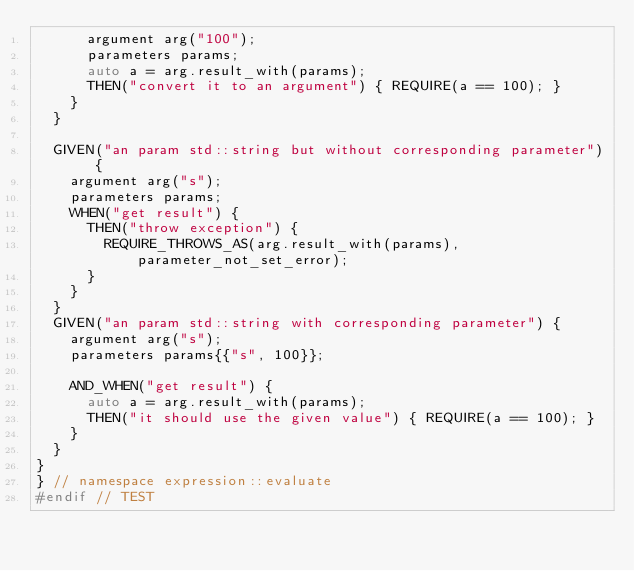Convert code to text. <code><loc_0><loc_0><loc_500><loc_500><_C++_>      argument arg("100");
      parameters params;
      auto a = arg.result_with(params);
      THEN("convert it to an argument") { REQUIRE(a == 100); }
    }
  }

  GIVEN("an param std::string but without corresponding parameter") {
    argument arg("s");
    parameters params;
    WHEN("get result") {
      THEN("throw exception") {
        REQUIRE_THROWS_AS(arg.result_with(params), parameter_not_set_error);
      }
    }
  }
  GIVEN("an param std::string with corresponding parameter") {
    argument arg("s");
    parameters params{{"s", 100}};

    AND_WHEN("get result") {
      auto a = arg.result_with(params);
      THEN("it should use the given value") { REQUIRE(a == 100); }
    }
  }
}
} // namespace expression::evaluate
#endif // TEST</code> 